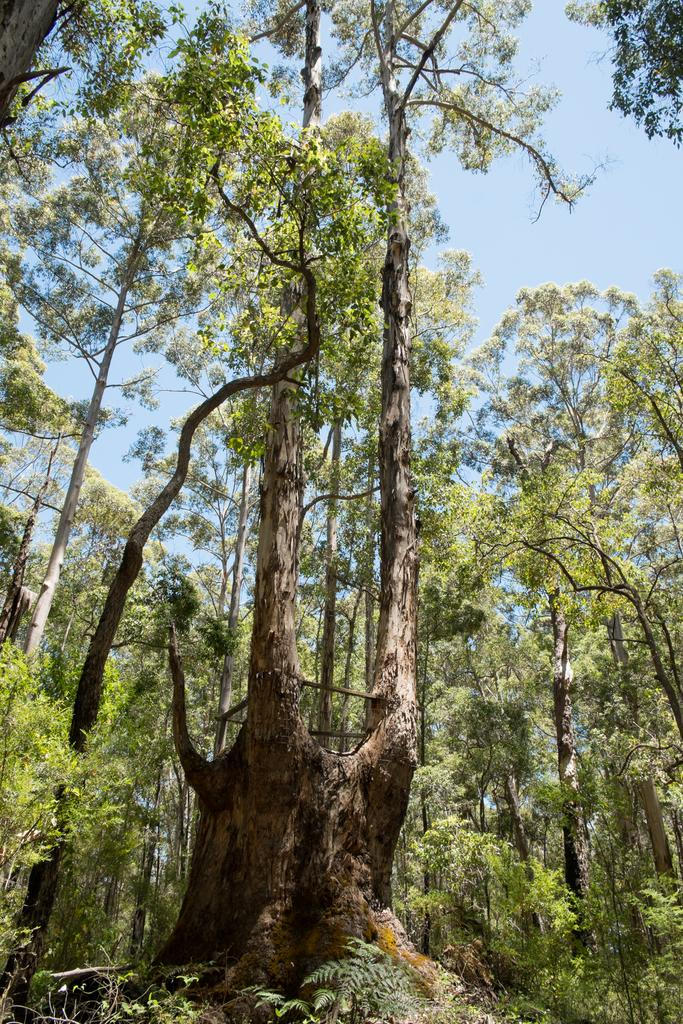What type of vegetation is present on the ground in the image? There are trees on the ground in the image. What part of the natural environment is visible in the image? The sky is visible at the top of the image. How many thumbs can be seen in the image? There are no thumbs visible in the image. What type of stew is being prepared in the image? There is no stew or cooking activity present in the image. 